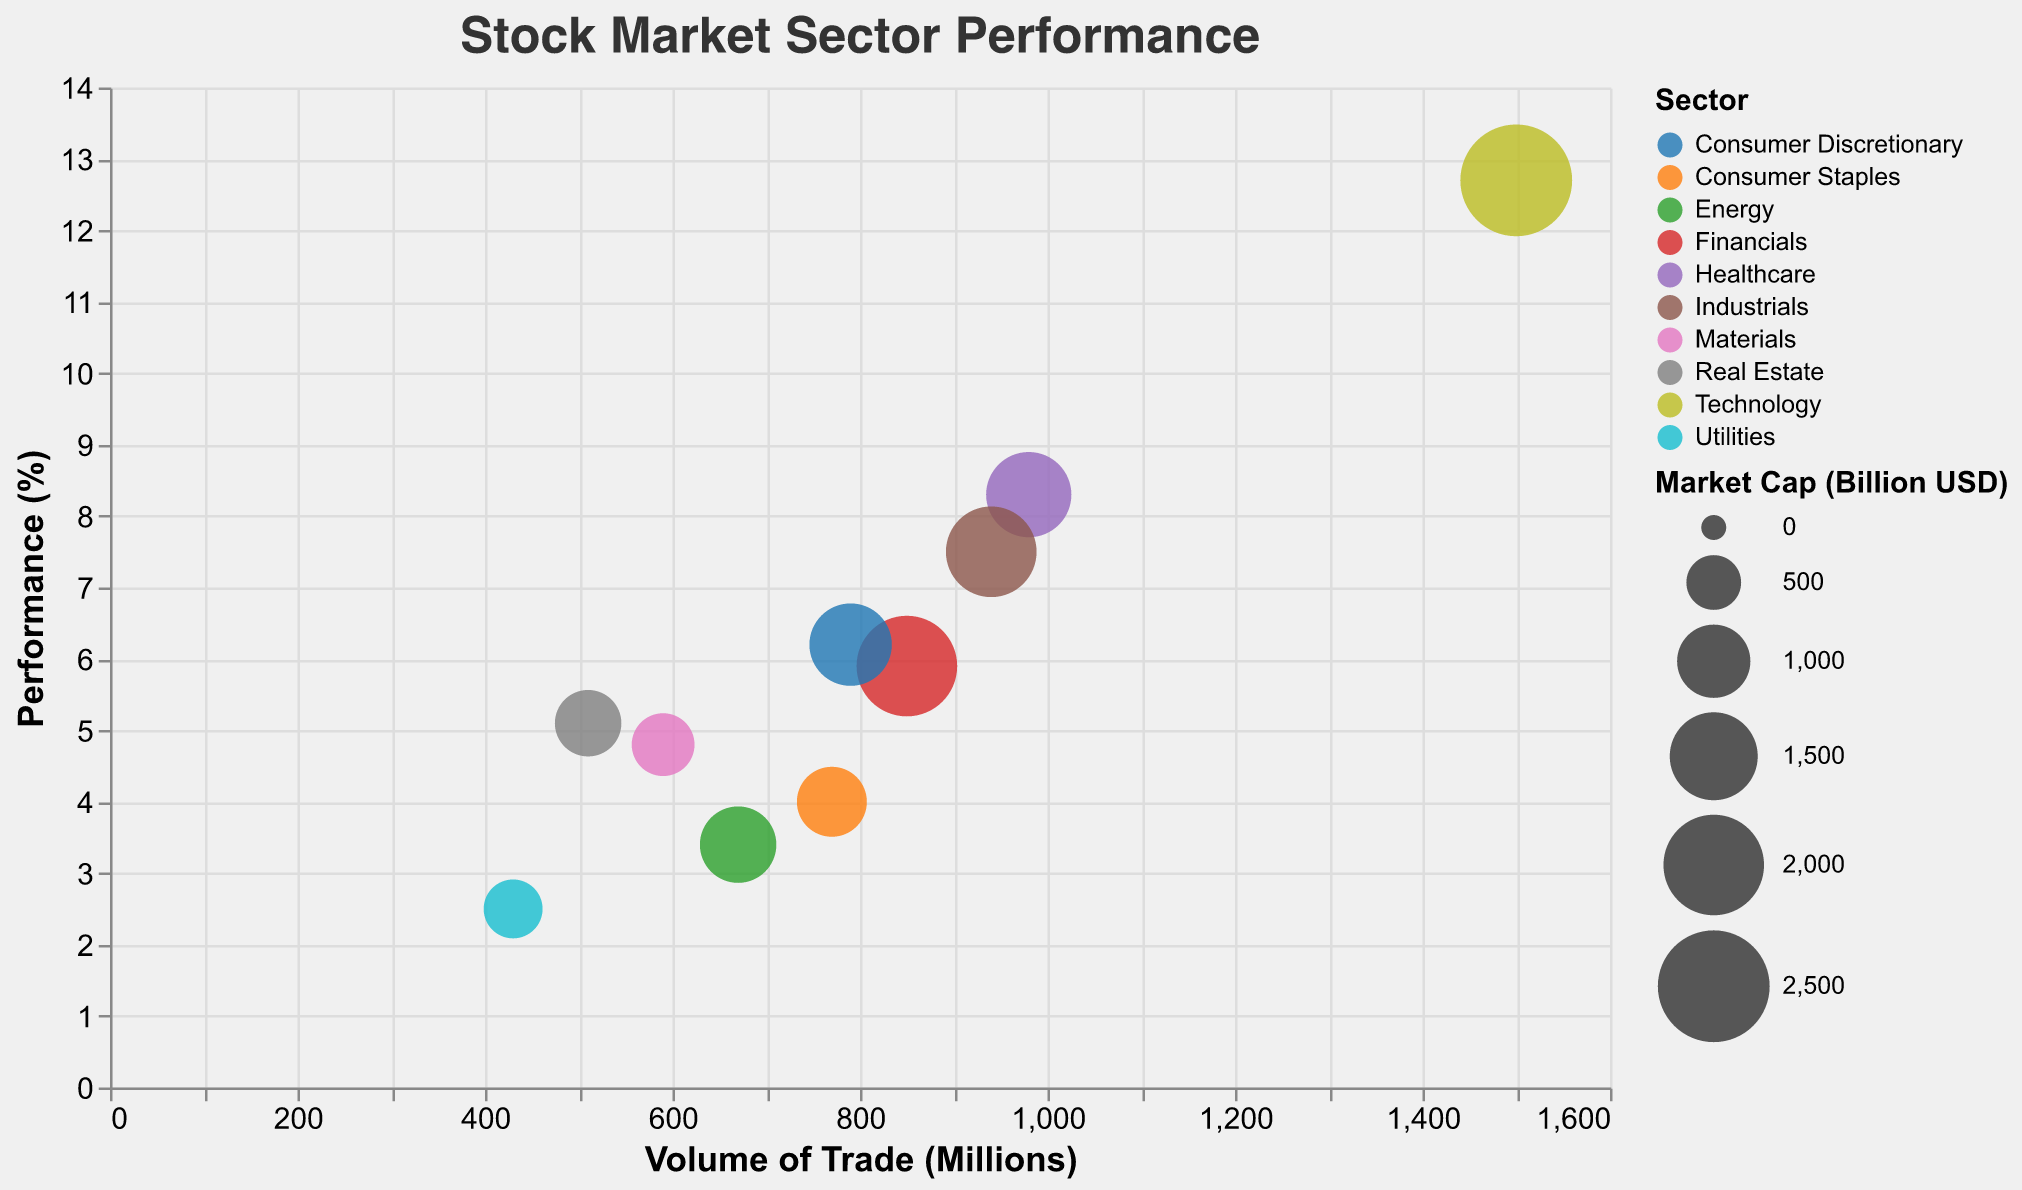What's the sector with the highest performance? By looking at the y-axis representing Performance (%), the bubble for Technology is at the highest y-position, indicating it has the highest performance.
Answer: Technology Which sector has the lowest volume of trade? By examining the x-axis representing Volume of Trade (Millions), the bubble for Utilities is at the far left, indicating it has the lowest volume of trade.
Answer: Utilities What sector has the largest market cap? Market cap is represented by the size of the bubbles; the largest bubble corresponds to the Technology sector.
Answer: Technology Compare performance between the Healthcare and Energy sectors. Which one is higher? By locating both Healthcare and Energy sectors on the y-axis, the bubble for Healthcare is placed higher than Energy, indicating higher performance.
Answer: Healthcare Which sector has a volume of trade closest to 1000 million? By examining the x-axis, the Healthcare sector is closest to the 1000 mark on the volume of trade scale.
Answer: Healthcare What is the performance of the Industrials sector? Looking at the bubble labeled Industrials and its corresponding position on the y-axis, the performance is around 7.5%.
Answer: 7.5% How does market cap compare between Financials and Consumer Discretionary sectors? Financials has a larger bubble (market cap) than Consumer Discretionary, indicating a larger market cap.
Answer: Financials Which sector has performance above 5% but below 7%? By looking at the interval on the y-axis between 5% and 7%, the sectors identified within this range are Financials and Real Estate (smaller bubble), thus Real Estate is the sector that meets the criteria.
Answer: Financials and Consumer Discretionary What is the volume of trade for the Materials sector? The bubble labeled Materials corresponds to a position around 590 on the x-axis.
Answer: 590 million How many sectors have a performance greater than 6%? By examining the y-axis, the sectors with performance greater than 6% are Technology, Healthcare, Consumer Discretionary, and Industrials.
Answer: 4 